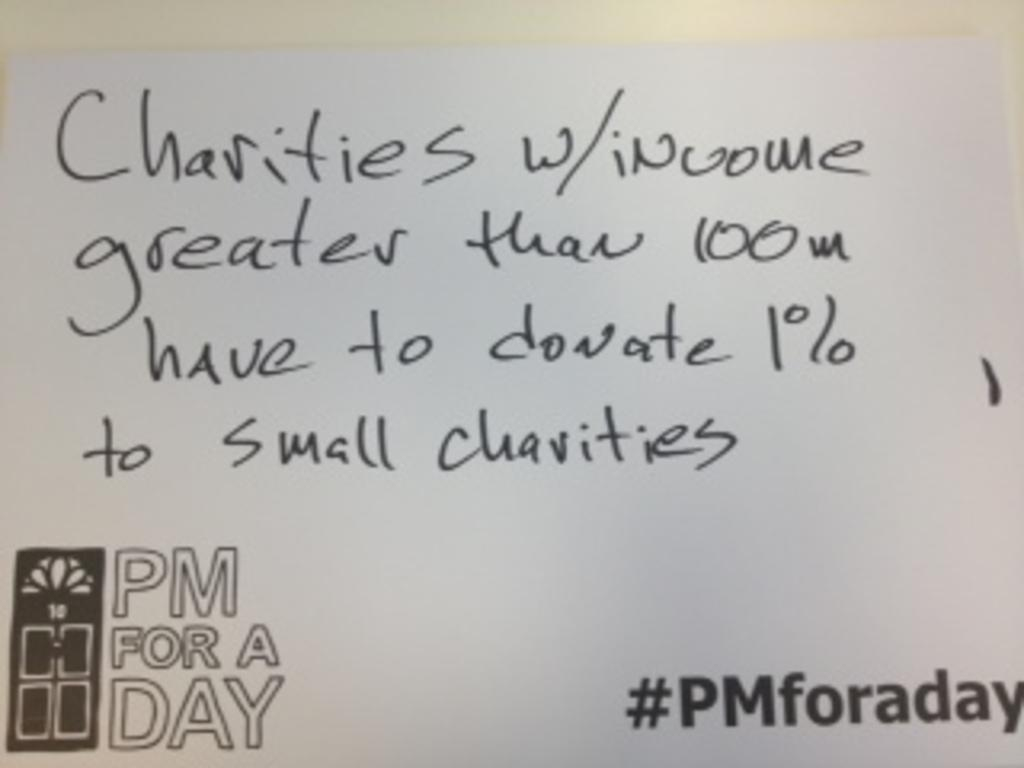<image>
Present a compact description of the photo's key features. A message from a PM for a day saying larger charities should have to donate to smaller ones. 